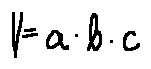<formula> <loc_0><loc_0><loc_500><loc_500>V = a \cdot b \cdot c</formula> 